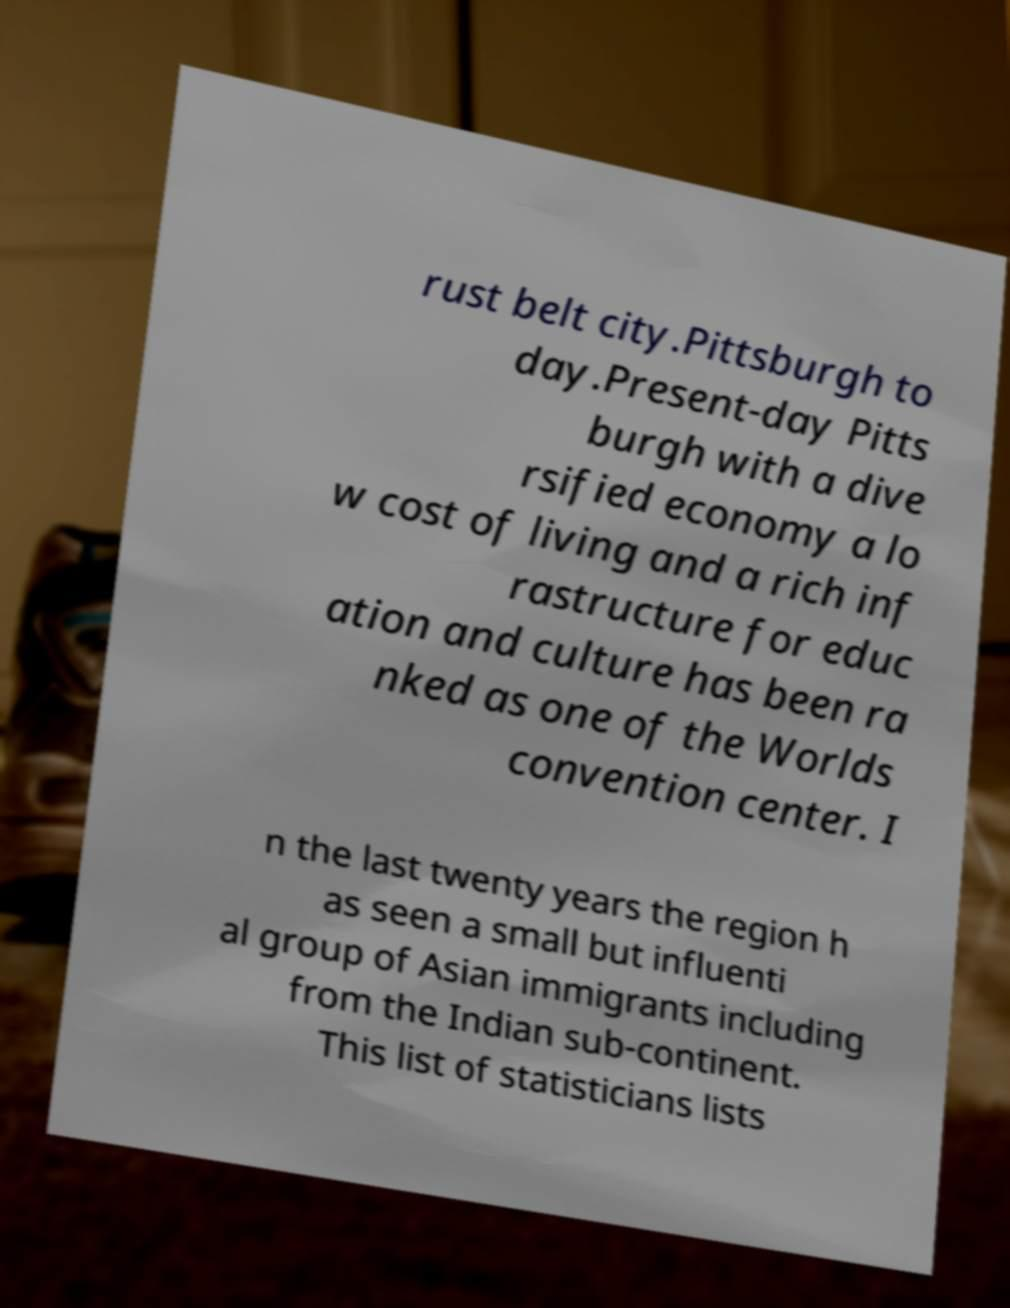I need the written content from this picture converted into text. Can you do that? rust belt city.Pittsburgh to day.Present-day Pitts burgh with a dive rsified economy a lo w cost of living and a rich inf rastructure for educ ation and culture has been ra nked as one of the Worlds convention center. I n the last twenty years the region h as seen a small but influenti al group of Asian immigrants including from the Indian sub-continent. This list of statisticians lists 